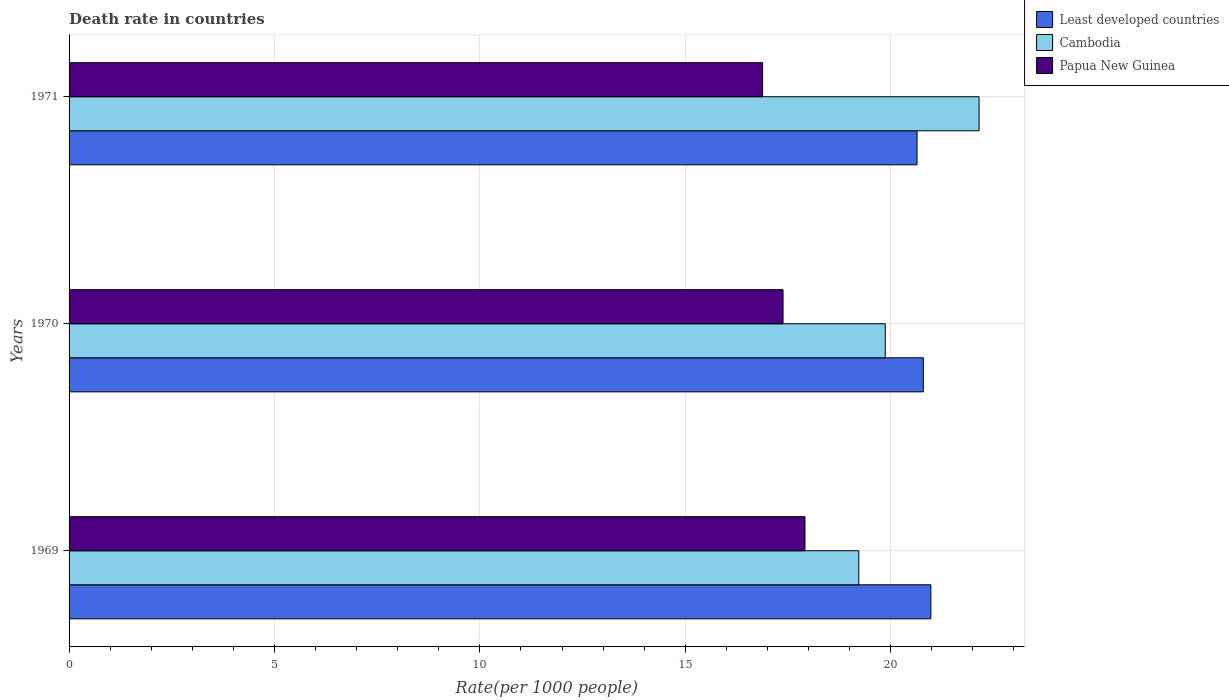How many different coloured bars are there?
Your response must be concise. 3. Are the number of bars per tick equal to the number of legend labels?
Provide a succinct answer. Yes. How many bars are there on the 1st tick from the bottom?
Keep it short and to the point. 3. What is the label of the 3rd group of bars from the top?
Ensure brevity in your answer.  1969. In how many cases, is the number of bars for a given year not equal to the number of legend labels?
Give a very brief answer. 0. What is the death rate in Least developed countries in 1969?
Offer a very short reply. 20.98. Across all years, what is the maximum death rate in Least developed countries?
Your answer should be very brief. 20.98. Across all years, what is the minimum death rate in Least developed countries?
Offer a terse response. 20.64. In which year was the death rate in Least developed countries maximum?
Your response must be concise. 1969. What is the total death rate in Papua New Guinea in the graph?
Ensure brevity in your answer.  52.18. What is the difference between the death rate in Cambodia in 1969 and that in 1971?
Your answer should be very brief. -2.93. What is the difference between the death rate in Least developed countries in 1971 and the death rate in Cambodia in 1969?
Your answer should be compact. 1.42. What is the average death rate in Papua New Guinea per year?
Offer a very short reply. 17.39. In the year 1970, what is the difference between the death rate in Cambodia and death rate in Least developed countries?
Give a very brief answer. -0.93. What is the ratio of the death rate in Cambodia in 1969 to that in 1971?
Your answer should be very brief. 0.87. Is the death rate in Papua New Guinea in 1970 less than that in 1971?
Ensure brevity in your answer.  No. What is the difference between the highest and the second highest death rate in Least developed countries?
Offer a terse response. 0.18. What is the difference between the highest and the lowest death rate in Least developed countries?
Keep it short and to the point. 0.34. Is the sum of the death rate in Cambodia in 1969 and 1970 greater than the maximum death rate in Papua New Guinea across all years?
Provide a short and direct response. Yes. What does the 3rd bar from the top in 1970 represents?
Ensure brevity in your answer.  Least developed countries. What does the 3rd bar from the bottom in 1970 represents?
Keep it short and to the point. Papua New Guinea. How many bars are there?
Give a very brief answer. 9. What is the difference between two consecutive major ticks on the X-axis?
Keep it short and to the point. 5. Does the graph contain grids?
Offer a terse response. Yes. Where does the legend appear in the graph?
Provide a short and direct response. Top right. How many legend labels are there?
Keep it short and to the point. 3. How are the legend labels stacked?
Offer a very short reply. Vertical. What is the title of the graph?
Give a very brief answer. Death rate in countries. Does "High income: OECD" appear as one of the legend labels in the graph?
Keep it short and to the point. No. What is the label or title of the X-axis?
Make the answer very short. Rate(per 1000 people). What is the Rate(per 1000 people) of Least developed countries in 1969?
Offer a terse response. 20.98. What is the Rate(per 1000 people) in Cambodia in 1969?
Your response must be concise. 19.23. What is the Rate(per 1000 people) of Papua New Guinea in 1969?
Provide a short and direct response. 17.91. What is the Rate(per 1000 people) in Least developed countries in 1970?
Make the answer very short. 20.79. What is the Rate(per 1000 people) in Cambodia in 1970?
Make the answer very short. 19.87. What is the Rate(per 1000 people) in Papua New Guinea in 1970?
Make the answer very short. 17.38. What is the Rate(per 1000 people) of Least developed countries in 1971?
Offer a terse response. 20.64. What is the Rate(per 1000 people) of Cambodia in 1971?
Provide a short and direct response. 22.15. What is the Rate(per 1000 people) of Papua New Guinea in 1971?
Ensure brevity in your answer.  16.88. Across all years, what is the maximum Rate(per 1000 people) of Least developed countries?
Keep it short and to the point. 20.98. Across all years, what is the maximum Rate(per 1000 people) in Cambodia?
Give a very brief answer. 22.15. Across all years, what is the maximum Rate(per 1000 people) of Papua New Guinea?
Your answer should be very brief. 17.91. Across all years, what is the minimum Rate(per 1000 people) in Least developed countries?
Offer a very short reply. 20.64. Across all years, what is the minimum Rate(per 1000 people) in Cambodia?
Your answer should be compact. 19.23. Across all years, what is the minimum Rate(per 1000 people) of Papua New Guinea?
Give a very brief answer. 16.88. What is the total Rate(per 1000 people) in Least developed countries in the graph?
Your answer should be very brief. 62.42. What is the total Rate(per 1000 people) of Cambodia in the graph?
Your answer should be very brief. 61.24. What is the total Rate(per 1000 people) in Papua New Guinea in the graph?
Provide a short and direct response. 52.18. What is the difference between the Rate(per 1000 people) of Least developed countries in 1969 and that in 1970?
Your answer should be compact. 0.18. What is the difference between the Rate(per 1000 people) in Cambodia in 1969 and that in 1970?
Keep it short and to the point. -0.64. What is the difference between the Rate(per 1000 people) in Papua New Guinea in 1969 and that in 1970?
Ensure brevity in your answer.  0.53. What is the difference between the Rate(per 1000 people) of Least developed countries in 1969 and that in 1971?
Keep it short and to the point. 0.34. What is the difference between the Rate(per 1000 people) in Cambodia in 1969 and that in 1971?
Provide a short and direct response. -2.93. What is the difference between the Rate(per 1000 people) of Papua New Guinea in 1969 and that in 1971?
Offer a terse response. 1.03. What is the difference between the Rate(per 1000 people) in Least developed countries in 1970 and that in 1971?
Offer a very short reply. 0.15. What is the difference between the Rate(per 1000 people) of Cambodia in 1970 and that in 1971?
Provide a short and direct response. -2.28. What is the difference between the Rate(per 1000 people) of Papua New Guinea in 1970 and that in 1971?
Your answer should be compact. 0.5. What is the difference between the Rate(per 1000 people) in Least developed countries in 1969 and the Rate(per 1000 people) in Cambodia in 1970?
Provide a short and direct response. 1.11. What is the difference between the Rate(per 1000 people) of Least developed countries in 1969 and the Rate(per 1000 people) of Papua New Guinea in 1970?
Offer a terse response. 3.6. What is the difference between the Rate(per 1000 people) of Cambodia in 1969 and the Rate(per 1000 people) of Papua New Guinea in 1970?
Make the answer very short. 1.84. What is the difference between the Rate(per 1000 people) in Least developed countries in 1969 and the Rate(per 1000 people) in Cambodia in 1971?
Your answer should be compact. -1.17. What is the difference between the Rate(per 1000 people) of Least developed countries in 1969 and the Rate(per 1000 people) of Papua New Guinea in 1971?
Your answer should be very brief. 4.1. What is the difference between the Rate(per 1000 people) in Cambodia in 1969 and the Rate(per 1000 people) in Papua New Guinea in 1971?
Your answer should be very brief. 2.34. What is the difference between the Rate(per 1000 people) of Least developed countries in 1970 and the Rate(per 1000 people) of Cambodia in 1971?
Your answer should be very brief. -1.36. What is the difference between the Rate(per 1000 people) of Least developed countries in 1970 and the Rate(per 1000 people) of Papua New Guinea in 1971?
Your response must be concise. 3.91. What is the difference between the Rate(per 1000 people) of Cambodia in 1970 and the Rate(per 1000 people) of Papua New Guinea in 1971?
Keep it short and to the point. 2.98. What is the average Rate(per 1000 people) in Least developed countries per year?
Provide a succinct answer. 20.81. What is the average Rate(per 1000 people) of Cambodia per year?
Your answer should be very brief. 20.41. What is the average Rate(per 1000 people) in Papua New Guinea per year?
Keep it short and to the point. 17.39. In the year 1969, what is the difference between the Rate(per 1000 people) in Least developed countries and Rate(per 1000 people) in Cambodia?
Your response must be concise. 1.75. In the year 1969, what is the difference between the Rate(per 1000 people) of Least developed countries and Rate(per 1000 people) of Papua New Guinea?
Your answer should be very brief. 3.06. In the year 1969, what is the difference between the Rate(per 1000 people) in Cambodia and Rate(per 1000 people) in Papua New Guinea?
Make the answer very short. 1.31. In the year 1970, what is the difference between the Rate(per 1000 people) in Least developed countries and Rate(per 1000 people) in Cambodia?
Provide a short and direct response. 0.93. In the year 1970, what is the difference between the Rate(per 1000 people) in Least developed countries and Rate(per 1000 people) in Papua New Guinea?
Your answer should be compact. 3.42. In the year 1970, what is the difference between the Rate(per 1000 people) of Cambodia and Rate(per 1000 people) of Papua New Guinea?
Offer a very short reply. 2.49. In the year 1971, what is the difference between the Rate(per 1000 people) of Least developed countries and Rate(per 1000 people) of Cambodia?
Offer a very short reply. -1.51. In the year 1971, what is the difference between the Rate(per 1000 people) in Least developed countries and Rate(per 1000 people) in Papua New Guinea?
Your response must be concise. 3.76. In the year 1971, what is the difference between the Rate(per 1000 people) of Cambodia and Rate(per 1000 people) of Papua New Guinea?
Your answer should be compact. 5.27. What is the ratio of the Rate(per 1000 people) of Least developed countries in 1969 to that in 1970?
Keep it short and to the point. 1.01. What is the ratio of the Rate(per 1000 people) of Cambodia in 1969 to that in 1970?
Your answer should be very brief. 0.97. What is the ratio of the Rate(per 1000 people) in Papua New Guinea in 1969 to that in 1970?
Give a very brief answer. 1.03. What is the ratio of the Rate(per 1000 people) in Least developed countries in 1969 to that in 1971?
Provide a succinct answer. 1.02. What is the ratio of the Rate(per 1000 people) in Cambodia in 1969 to that in 1971?
Keep it short and to the point. 0.87. What is the ratio of the Rate(per 1000 people) in Papua New Guinea in 1969 to that in 1971?
Your answer should be very brief. 1.06. What is the ratio of the Rate(per 1000 people) in Least developed countries in 1970 to that in 1971?
Give a very brief answer. 1.01. What is the ratio of the Rate(per 1000 people) of Cambodia in 1970 to that in 1971?
Make the answer very short. 0.9. What is the ratio of the Rate(per 1000 people) of Papua New Guinea in 1970 to that in 1971?
Provide a succinct answer. 1.03. What is the difference between the highest and the second highest Rate(per 1000 people) of Least developed countries?
Offer a terse response. 0.18. What is the difference between the highest and the second highest Rate(per 1000 people) in Cambodia?
Offer a very short reply. 2.28. What is the difference between the highest and the second highest Rate(per 1000 people) in Papua New Guinea?
Your answer should be compact. 0.53. What is the difference between the highest and the lowest Rate(per 1000 people) of Least developed countries?
Make the answer very short. 0.34. What is the difference between the highest and the lowest Rate(per 1000 people) of Cambodia?
Your response must be concise. 2.93. What is the difference between the highest and the lowest Rate(per 1000 people) of Papua New Guinea?
Offer a very short reply. 1.03. 